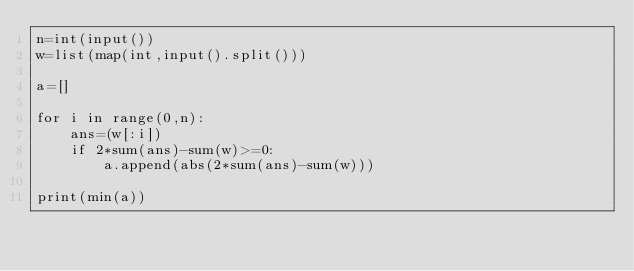<code> <loc_0><loc_0><loc_500><loc_500><_Python_>n=int(input())
w=list(map(int,input().split()))

a=[]

for i in range(0,n):
    ans=(w[:i])
    if 2*sum(ans)-sum(w)>=0:
        a.append(abs(2*sum(ans)-sum(w)))
        
print(min(a))</code> 